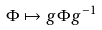<formula> <loc_0><loc_0><loc_500><loc_500>\Phi \mapsto g \Phi g ^ { - 1 }</formula> 